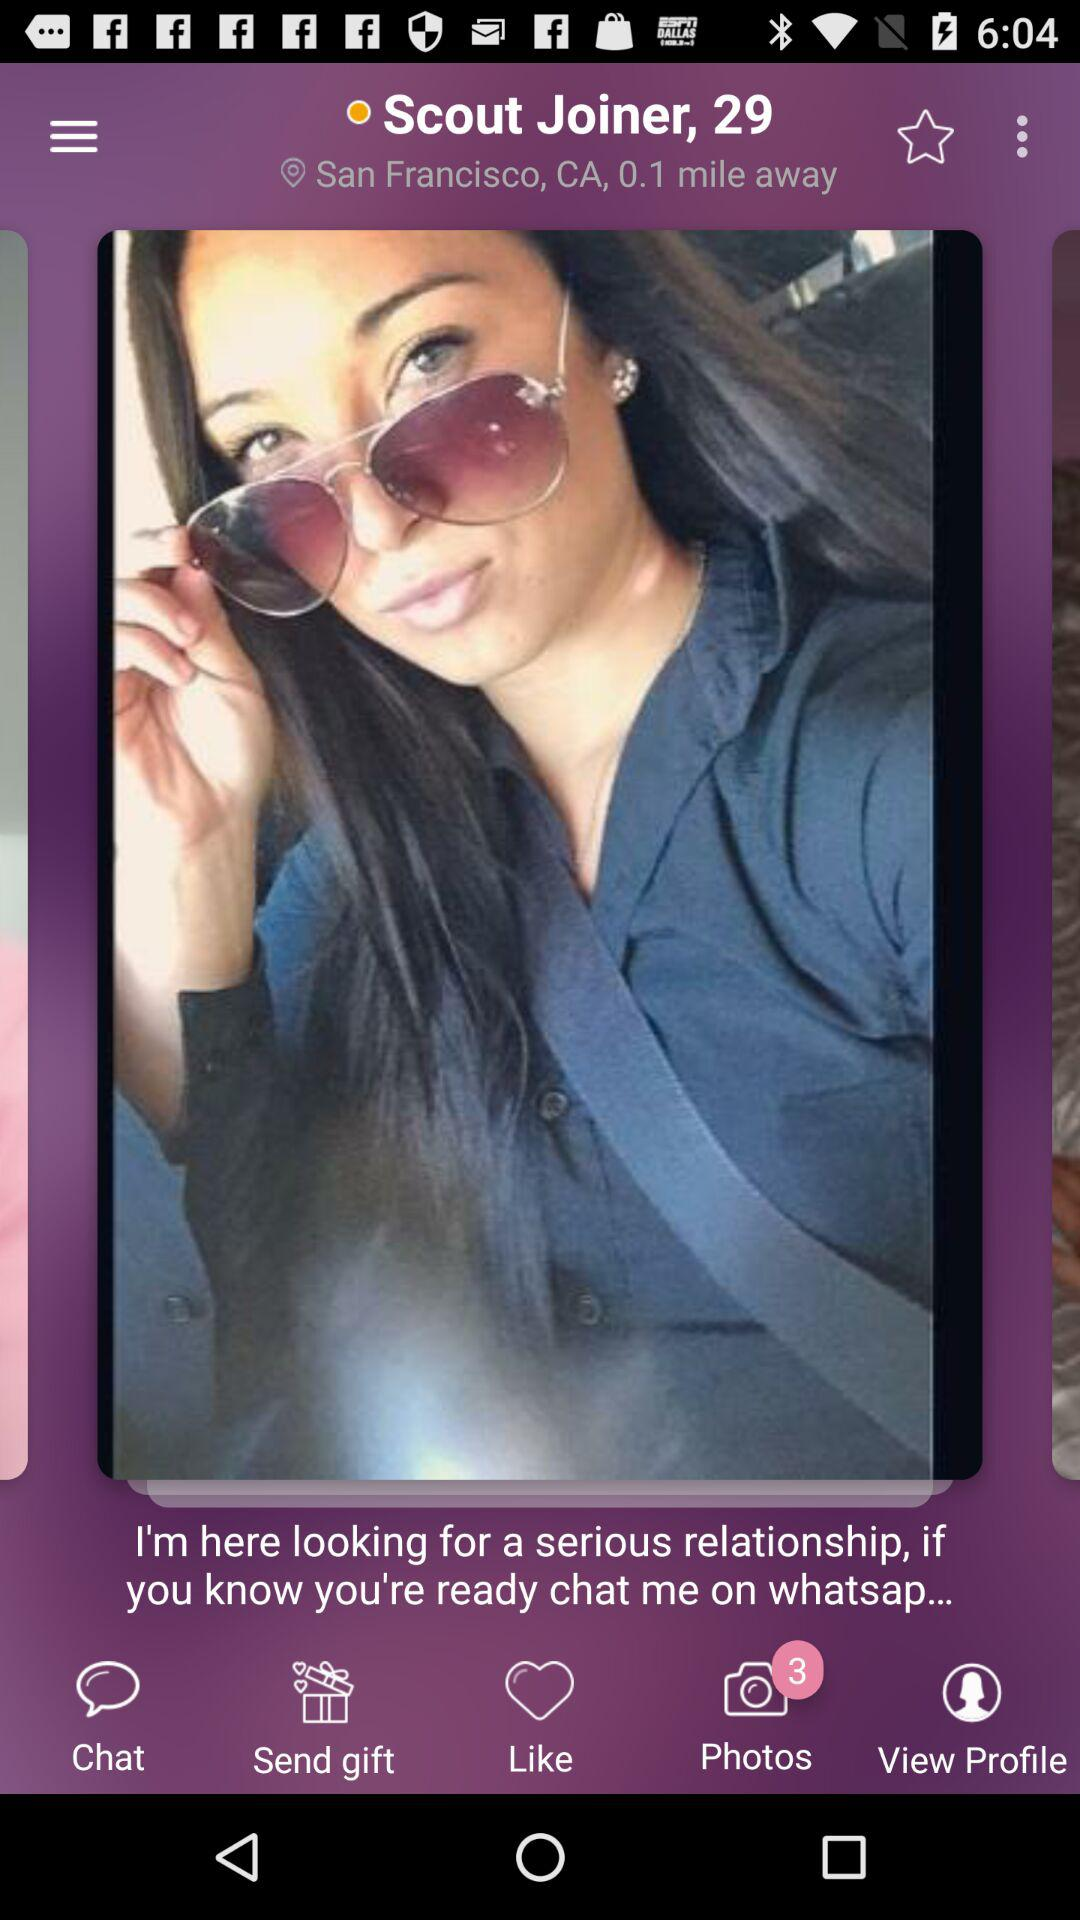What is the age of the person? The person is 29 years old. 